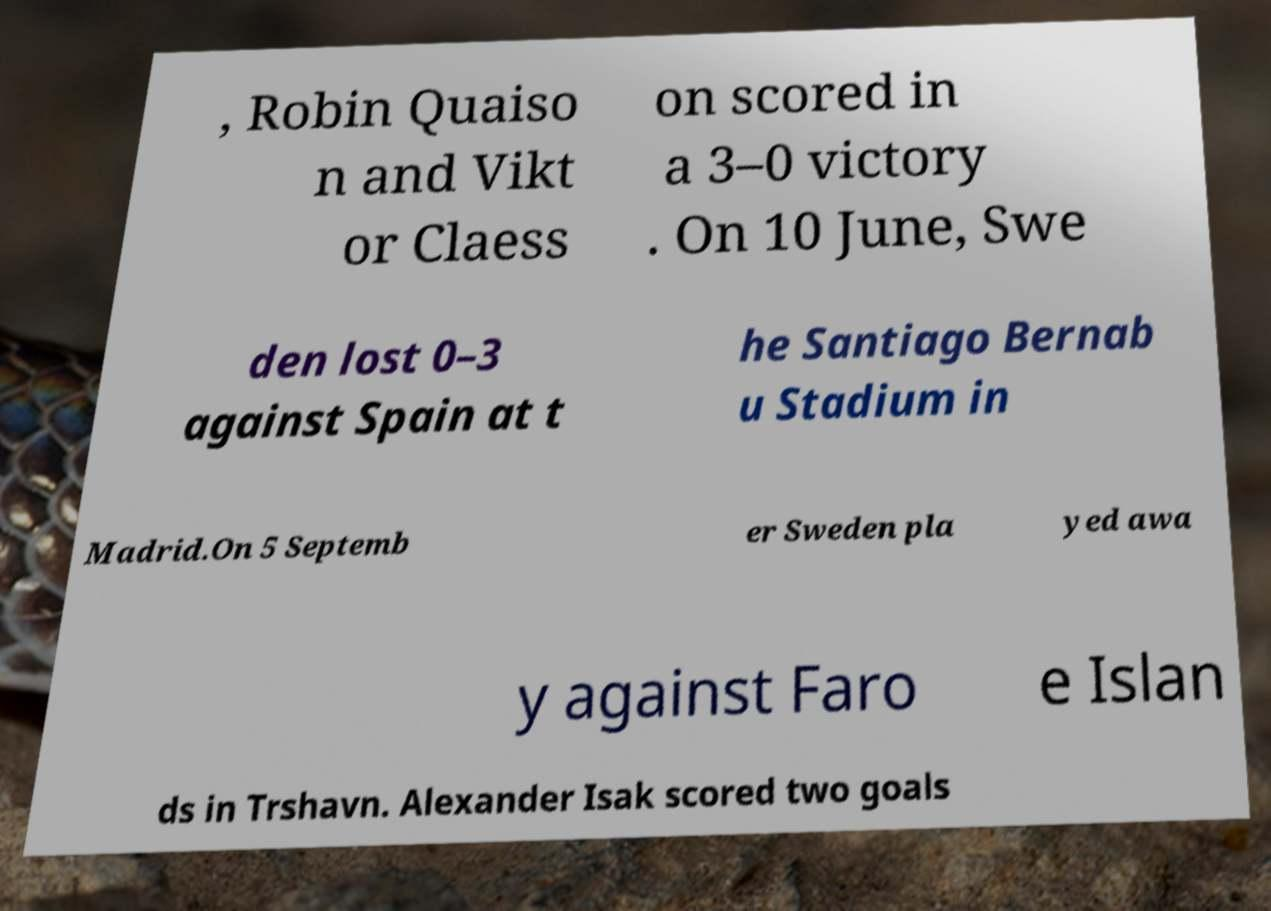Please identify and transcribe the text found in this image. , Robin Quaiso n and Vikt or Claess on scored in a 3–0 victory . On 10 June, Swe den lost 0–3 against Spain at t he Santiago Bernab u Stadium in Madrid.On 5 Septemb er Sweden pla yed awa y against Faro e Islan ds in Trshavn. Alexander Isak scored two goals 